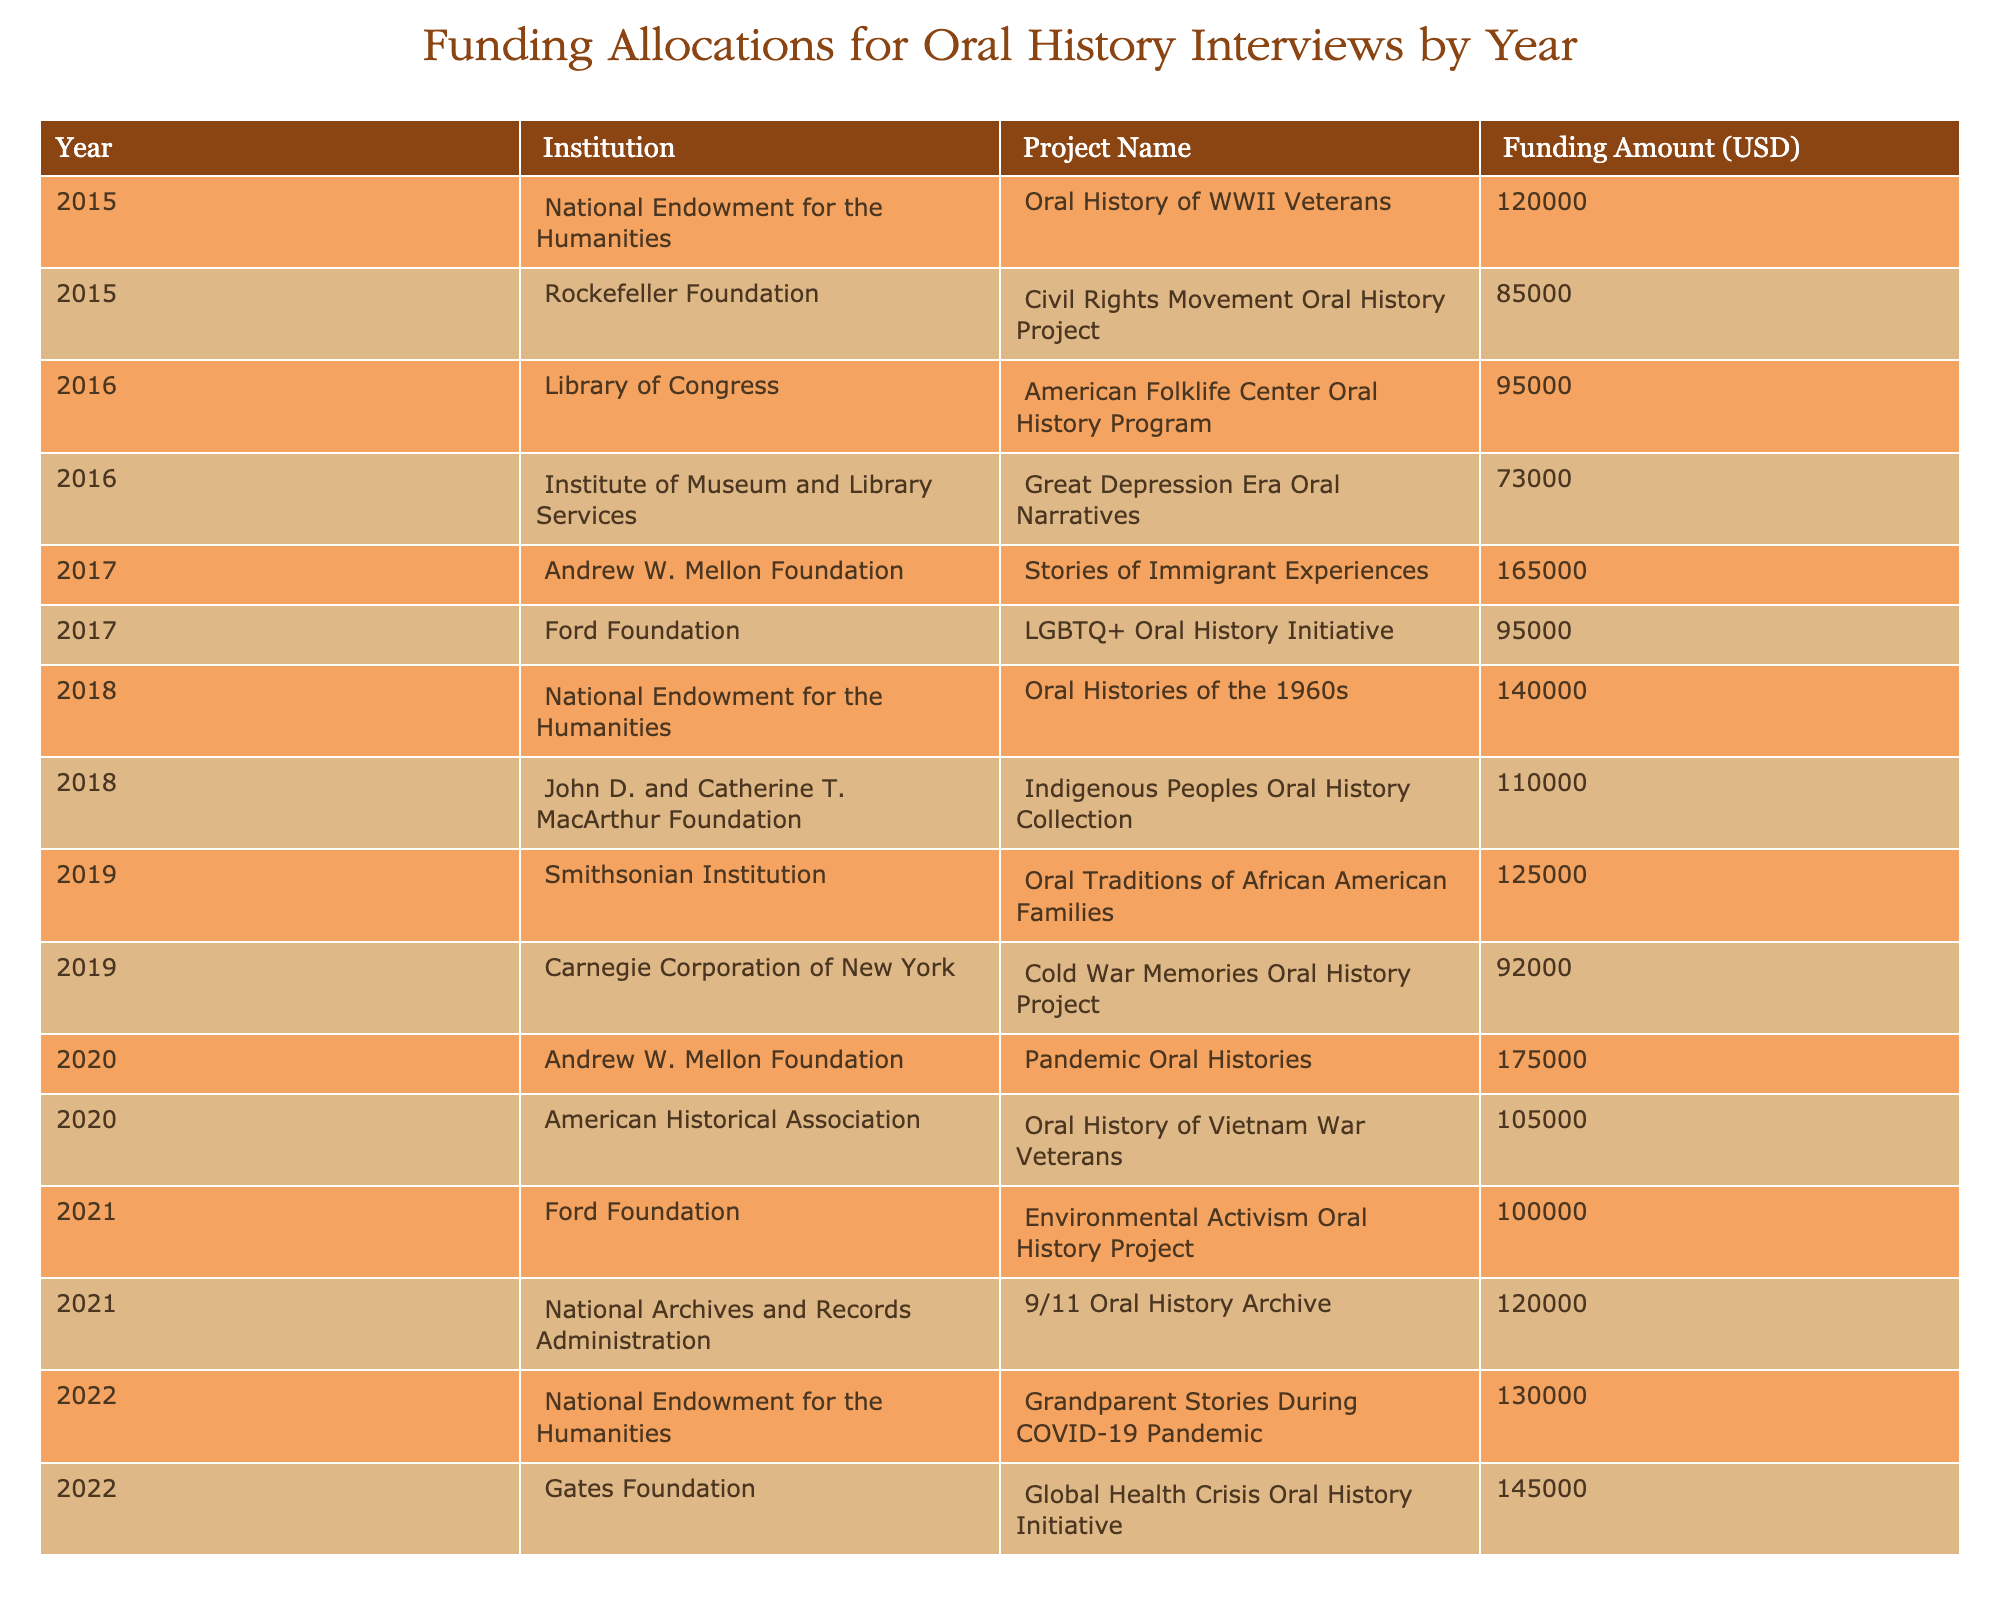What was the total funding allocated in 2015? In 2015, there were two projects listed: the Oral History of WWII Veterans with $120,000, and the Civil Rights Movement Oral History Project with $85,000. To find the total, we add these amounts: 120,000 + 85,000 = 205,000.
Answer: 205,000 Which institution funded the highest single project in 2020? In 2020, there were two projects: Pandemic Oral Histories funded by the Andrew W. Mellon Foundation for $175,000, and Oral History of Vietnam War Veterans funded by the American Historical Association for $105,000. The highest funding was $175,000 from the Andrew W. Mellon Foundation.
Answer: Andrew W. Mellon Foundation Did any institution fund projects in both 2019 and 2020? The table shows two projects in 2019 and two in 2020. The institutions for 2019 are the Smithsonian Institution and the Carnegie Corporation of New York; for 2020, they are the Andrew W. Mellon Foundation and the American Historical Association. Since there are no overlapping institutions, the answer is no.
Answer: No What is the average funding amount for oral history projects from 2018 to 2022? From 2018 to 2022, the funding amounts are: 140,000 (2018), 110,000 (2018), 125,000 (2019), 92000 (2019), 175,000 (2020), 105,000 (2020), 100,000 (2021), 120,000 (2021), 130,000 (2022), and 145,000 (2022). There are a total of 10 projects, and their sum is 1,050,000. Therefore, the average is 1,050,000 / 10 = 105,000.
Answer: 105,000 Which year saw the greatest increase in funding compared to the previous year? To determine the year with the greatest increase, we compare the total funding by year. In 2016, there was a decrease from 205,000 (2015) to 172,000 (2016; sum of projects), showing a decrease. For 2017, the amount rose to 260,000, which is an increase of 88,000 from 172,000 (2016). Comparing these, 2017 shows the greatest increase over the previous year.
Answer: 2017 